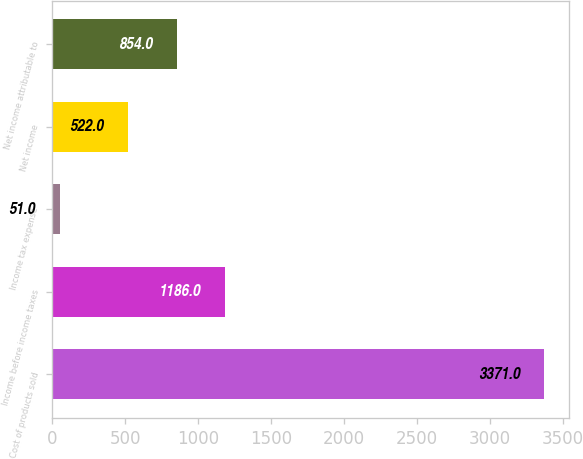<chart> <loc_0><loc_0><loc_500><loc_500><bar_chart><fcel>Cost of products sold<fcel>Income before income taxes<fcel>Income tax expense<fcel>Net income<fcel>Net income attributable to<nl><fcel>3371<fcel>1186<fcel>51<fcel>522<fcel>854<nl></chart> 